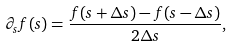<formula> <loc_0><loc_0><loc_500><loc_500>\partial _ { s } f ( s ) = \frac { f ( s + \Delta s ) - f ( s - \Delta s ) } { 2 \Delta s } ,</formula> 